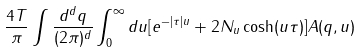Convert formula to latex. <formula><loc_0><loc_0><loc_500><loc_500>\frac { 4 T } { \pi } \int \frac { d ^ { d } q } { ( 2 \pi ) ^ { d } } \int _ { 0 } ^ { \infty } d u [ e ^ { - | \tau | u } + 2 N _ { u } \cosh ( u \tau ) ] A ( q , u )</formula> 